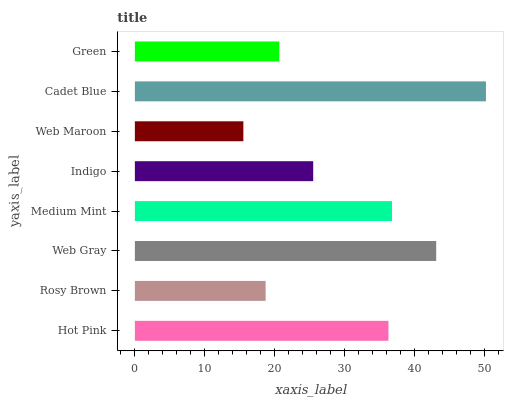Is Web Maroon the minimum?
Answer yes or no. Yes. Is Cadet Blue the maximum?
Answer yes or no. Yes. Is Rosy Brown the minimum?
Answer yes or no. No. Is Rosy Brown the maximum?
Answer yes or no. No. Is Hot Pink greater than Rosy Brown?
Answer yes or no. Yes. Is Rosy Brown less than Hot Pink?
Answer yes or no. Yes. Is Rosy Brown greater than Hot Pink?
Answer yes or no. No. Is Hot Pink less than Rosy Brown?
Answer yes or no. No. Is Hot Pink the high median?
Answer yes or no. Yes. Is Indigo the low median?
Answer yes or no. Yes. Is Indigo the high median?
Answer yes or no. No. Is Web Gray the low median?
Answer yes or no. No. 